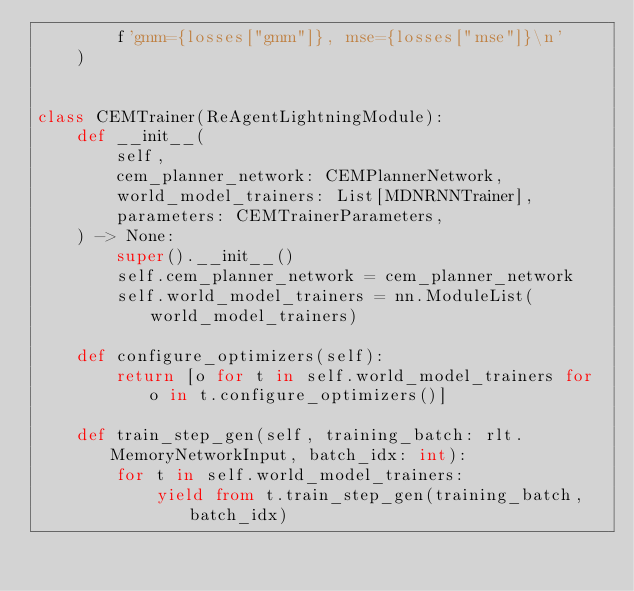Convert code to text. <code><loc_0><loc_0><loc_500><loc_500><_Python_>        f'gmm={losses["gmm"]}, mse={losses["mse"]}\n'
    )


class CEMTrainer(ReAgentLightningModule):
    def __init__(
        self,
        cem_planner_network: CEMPlannerNetwork,
        world_model_trainers: List[MDNRNNTrainer],
        parameters: CEMTrainerParameters,
    ) -> None:
        super().__init__()
        self.cem_planner_network = cem_planner_network
        self.world_model_trainers = nn.ModuleList(world_model_trainers)

    def configure_optimizers(self):
        return [o for t in self.world_model_trainers for o in t.configure_optimizers()]

    def train_step_gen(self, training_batch: rlt.MemoryNetworkInput, batch_idx: int):
        for t in self.world_model_trainers:
            yield from t.train_step_gen(training_batch, batch_idx)
</code> 